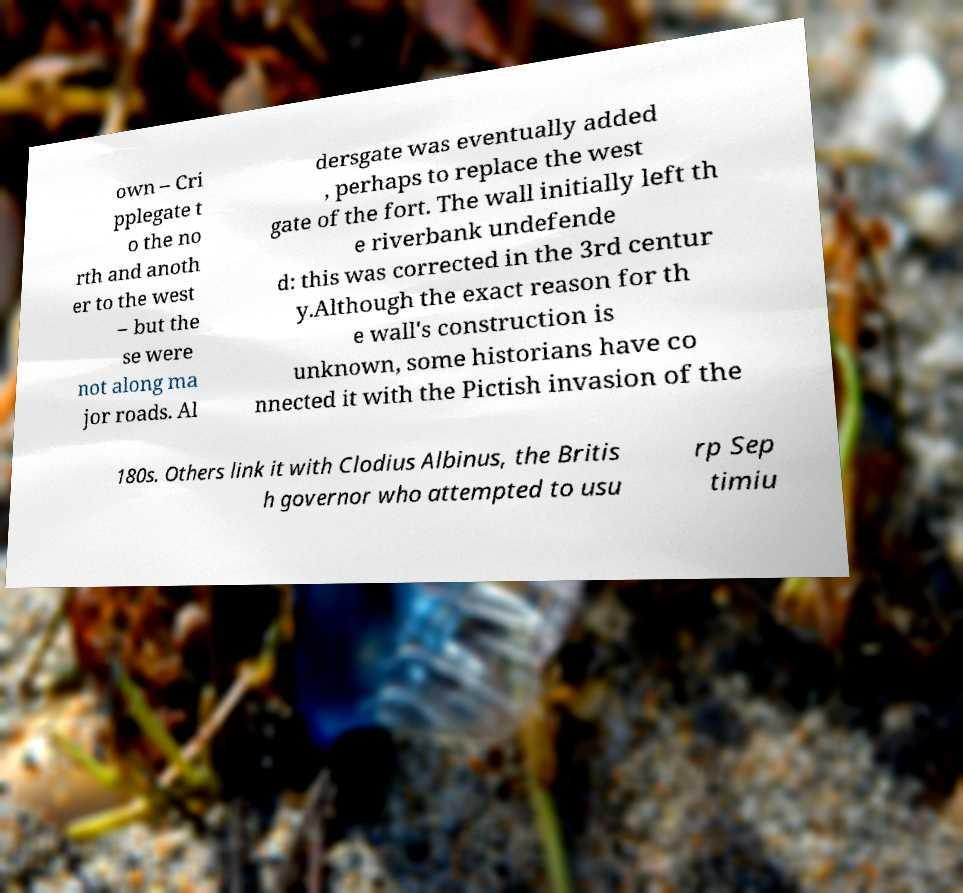Could you assist in decoding the text presented in this image and type it out clearly? own – Cri pplegate t o the no rth and anoth er to the west – but the se were not along ma jor roads. Al dersgate was eventually added , perhaps to replace the west gate of the fort. The wall initially left th e riverbank undefende d: this was corrected in the 3rd centur y.Although the exact reason for th e wall's construction is unknown, some historians have co nnected it with the Pictish invasion of the 180s. Others link it with Clodius Albinus, the Britis h governor who attempted to usu rp Sep timiu 